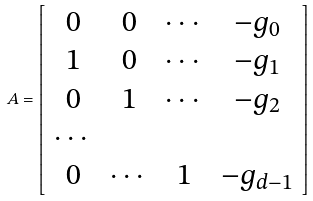Convert formula to latex. <formula><loc_0><loc_0><loc_500><loc_500>A = \left [ \begin{array} { c c c c } 0 & 0 & \cdots & - g _ { 0 } \\ 1 & 0 & \cdots & - g _ { 1 } \\ 0 & 1 & \cdots & - g _ { 2 } \\ \cdots & & & \\ 0 & \cdots & 1 & - g _ { d - 1 } \\ \end{array} \right ]</formula> 